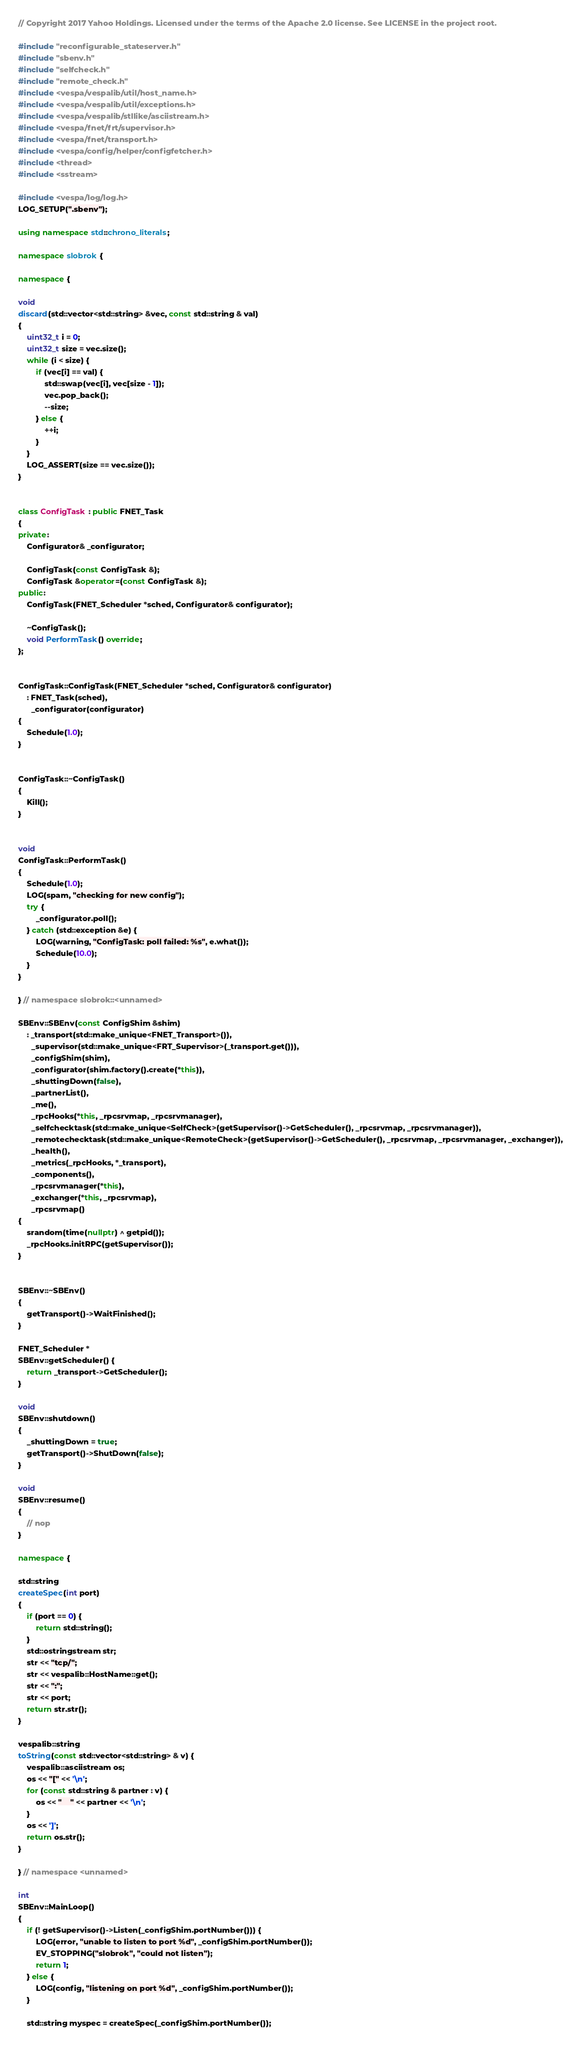<code> <loc_0><loc_0><loc_500><loc_500><_C++_>// Copyright 2017 Yahoo Holdings. Licensed under the terms of the Apache 2.0 license. See LICENSE in the project root.

#include "reconfigurable_stateserver.h"
#include "sbenv.h"
#include "selfcheck.h"
#include "remote_check.h"
#include <vespa/vespalib/util/host_name.h>
#include <vespa/vespalib/util/exceptions.h>
#include <vespa/vespalib/stllike/asciistream.h>
#include <vespa/fnet/frt/supervisor.h>
#include <vespa/fnet/transport.h>
#include <vespa/config/helper/configfetcher.h>
#include <thread>
#include <sstream>

#include <vespa/log/log.h>
LOG_SETUP(".sbenv");

using namespace std::chrono_literals;

namespace slobrok {

namespace {

void
discard(std::vector<std::string> &vec, const std::string & val)
{
    uint32_t i = 0;
    uint32_t size = vec.size();
    while (i < size) {
        if (vec[i] == val) {
            std::swap(vec[i], vec[size - 1]);
            vec.pop_back();
            --size;
        } else {
            ++i;
        }
    }
    LOG_ASSERT(size == vec.size());
}


class ConfigTask : public FNET_Task
{
private:
    Configurator& _configurator;

    ConfigTask(const ConfigTask &);
    ConfigTask &operator=(const ConfigTask &);
public:
    ConfigTask(FNET_Scheduler *sched, Configurator& configurator);

    ~ConfigTask();
    void PerformTask() override;
};


ConfigTask::ConfigTask(FNET_Scheduler *sched, Configurator& configurator)
    : FNET_Task(sched),
      _configurator(configurator)
{
    Schedule(1.0);
}


ConfigTask::~ConfigTask()
{
    Kill();
}


void
ConfigTask::PerformTask()
{
    Schedule(1.0);
    LOG(spam, "checking for new config");
    try {
        _configurator.poll();
    } catch (std::exception &e) {
        LOG(warning, "ConfigTask: poll failed: %s", e.what());
        Schedule(10.0);
    }
}

} // namespace slobrok::<unnamed>

SBEnv::SBEnv(const ConfigShim &shim)
    : _transport(std::make_unique<FNET_Transport>()),
      _supervisor(std::make_unique<FRT_Supervisor>(_transport.get())),
      _configShim(shim),
      _configurator(shim.factory().create(*this)),
      _shuttingDown(false),
      _partnerList(),
      _me(),
      _rpcHooks(*this, _rpcsrvmap, _rpcsrvmanager),
      _selfchecktask(std::make_unique<SelfCheck>(getSupervisor()->GetScheduler(), _rpcsrvmap, _rpcsrvmanager)),
      _remotechecktask(std::make_unique<RemoteCheck>(getSupervisor()->GetScheduler(), _rpcsrvmap, _rpcsrvmanager, _exchanger)),
      _health(),
      _metrics(_rpcHooks, *_transport),
      _components(),
      _rpcsrvmanager(*this),
      _exchanger(*this, _rpcsrvmap),
      _rpcsrvmap()
{
    srandom(time(nullptr) ^ getpid());
    _rpcHooks.initRPC(getSupervisor());
}


SBEnv::~SBEnv()
{
    getTransport()->WaitFinished();
}

FNET_Scheduler *
SBEnv::getScheduler() {
    return _transport->GetScheduler();
}

void
SBEnv::shutdown()
{
    _shuttingDown = true;
    getTransport()->ShutDown(false);
}

void
SBEnv::resume()
{
    // nop
}

namespace {

std::string
createSpec(int port)
{
    if (port == 0) {
        return std::string();
    }
    std::ostringstream str;
    str << "tcp/";
    str << vespalib::HostName::get();
    str << ":";
    str << port;
    return str.str();
}

vespalib::string
toString(const std::vector<std::string> & v) {
    vespalib::asciistream os;
    os << "[" << '\n';
    for (const std::string & partner : v) {
        os << "    " << partner << '\n';
    }
    os << ']';
    return os.str();
}

} // namespace <unnamed>

int
SBEnv::MainLoop()
{
    if (! getSupervisor()->Listen(_configShim.portNumber())) {
        LOG(error, "unable to listen to port %d", _configShim.portNumber());
        EV_STOPPING("slobrok", "could not listen");
        return 1;
    } else {
        LOG(config, "listening on port %d", _configShim.portNumber());
    }

    std::string myspec = createSpec(_configShim.portNumber());
</code> 